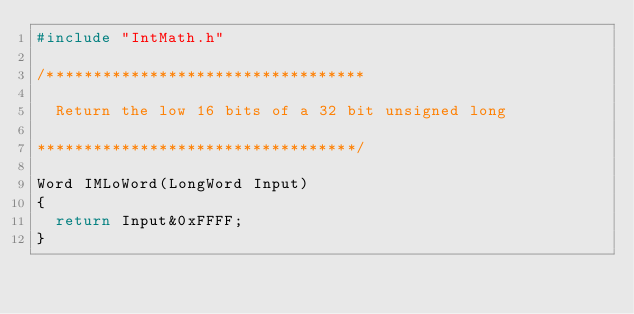Convert code to text. <code><loc_0><loc_0><loc_500><loc_500><_C_>#include "IntMath.h"

/**********************************

	Return the low 16 bits of a 32 bit unsigned long

**********************************/

Word IMLoWord(LongWord Input)
{
	return Input&0xFFFF;
}
</code> 